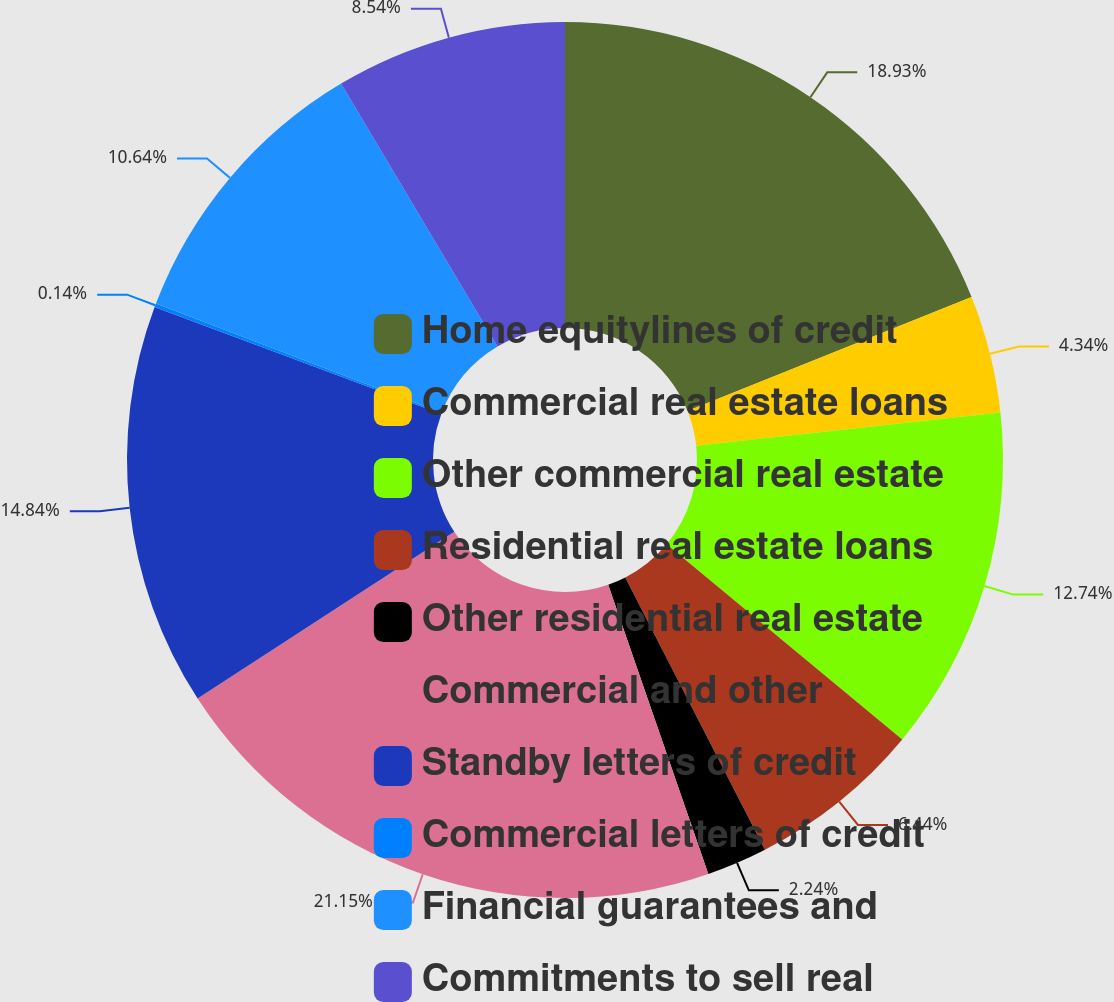Convert chart to OTSL. <chart><loc_0><loc_0><loc_500><loc_500><pie_chart><fcel>Home equitylines of credit<fcel>Commercial real estate loans<fcel>Other commercial real estate<fcel>Residential real estate loans<fcel>Other residential real estate<fcel>Commercial and other<fcel>Standby letters of credit<fcel>Commercial letters of credit<fcel>Financial guarantees and<fcel>Commitments to sell real<nl><fcel>18.93%<fcel>4.34%<fcel>12.74%<fcel>6.44%<fcel>2.24%<fcel>21.14%<fcel>14.84%<fcel>0.14%<fcel>10.64%<fcel>8.54%<nl></chart> 